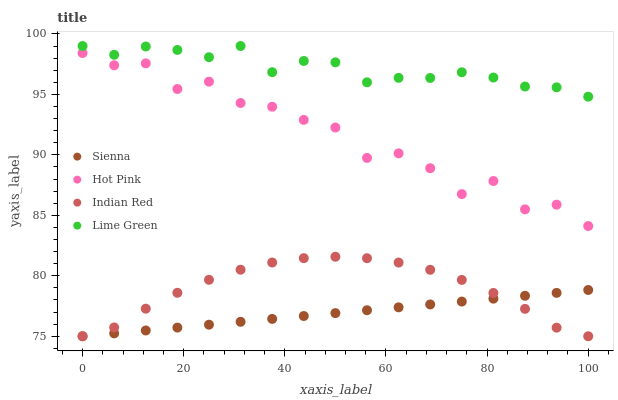Does Sienna have the minimum area under the curve?
Answer yes or no. Yes. Does Lime Green have the maximum area under the curve?
Answer yes or no. Yes. Does Hot Pink have the minimum area under the curve?
Answer yes or no. No. Does Hot Pink have the maximum area under the curve?
Answer yes or no. No. Is Sienna the smoothest?
Answer yes or no. Yes. Is Hot Pink the roughest?
Answer yes or no. Yes. Is Lime Green the smoothest?
Answer yes or no. No. Is Lime Green the roughest?
Answer yes or no. No. Does Sienna have the lowest value?
Answer yes or no. Yes. Does Hot Pink have the lowest value?
Answer yes or no. No. Does Lime Green have the highest value?
Answer yes or no. Yes. Does Hot Pink have the highest value?
Answer yes or no. No. Is Sienna less than Hot Pink?
Answer yes or no. Yes. Is Hot Pink greater than Sienna?
Answer yes or no. Yes. Does Indian Red intersect Sienna?
Answer yes or no. Yes. Is Indian Red less than Sienna?
Answer yes or no. No. Is Indian Red greater than Sienna?
Answer yes or no. No. Does Sienna intersect Hot Pink?
Answer yes or no. No. 